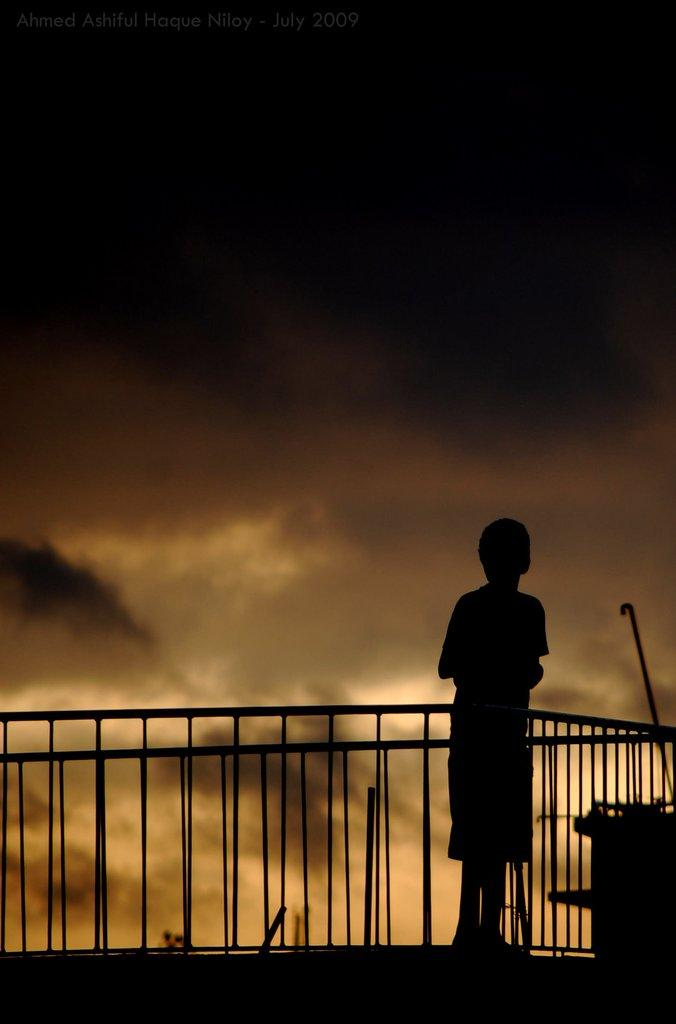What is the overall lighting condition of the image? The image is dark. What can be seen in the foreground of the image? There is a kid standing in the image. What is present in the image that serves as a barrier or divider? There is a fence in the image. What can be seen in the background of the image? The sky with clouds is visible in the background of the image. What type of wood is being used to create a paste in the image? There is no wood or paste present in the image. How many ants can be seen crawling on the fence in the image? There are no ants visible in the image; only the kid, fence, and sky with clouds are present. 